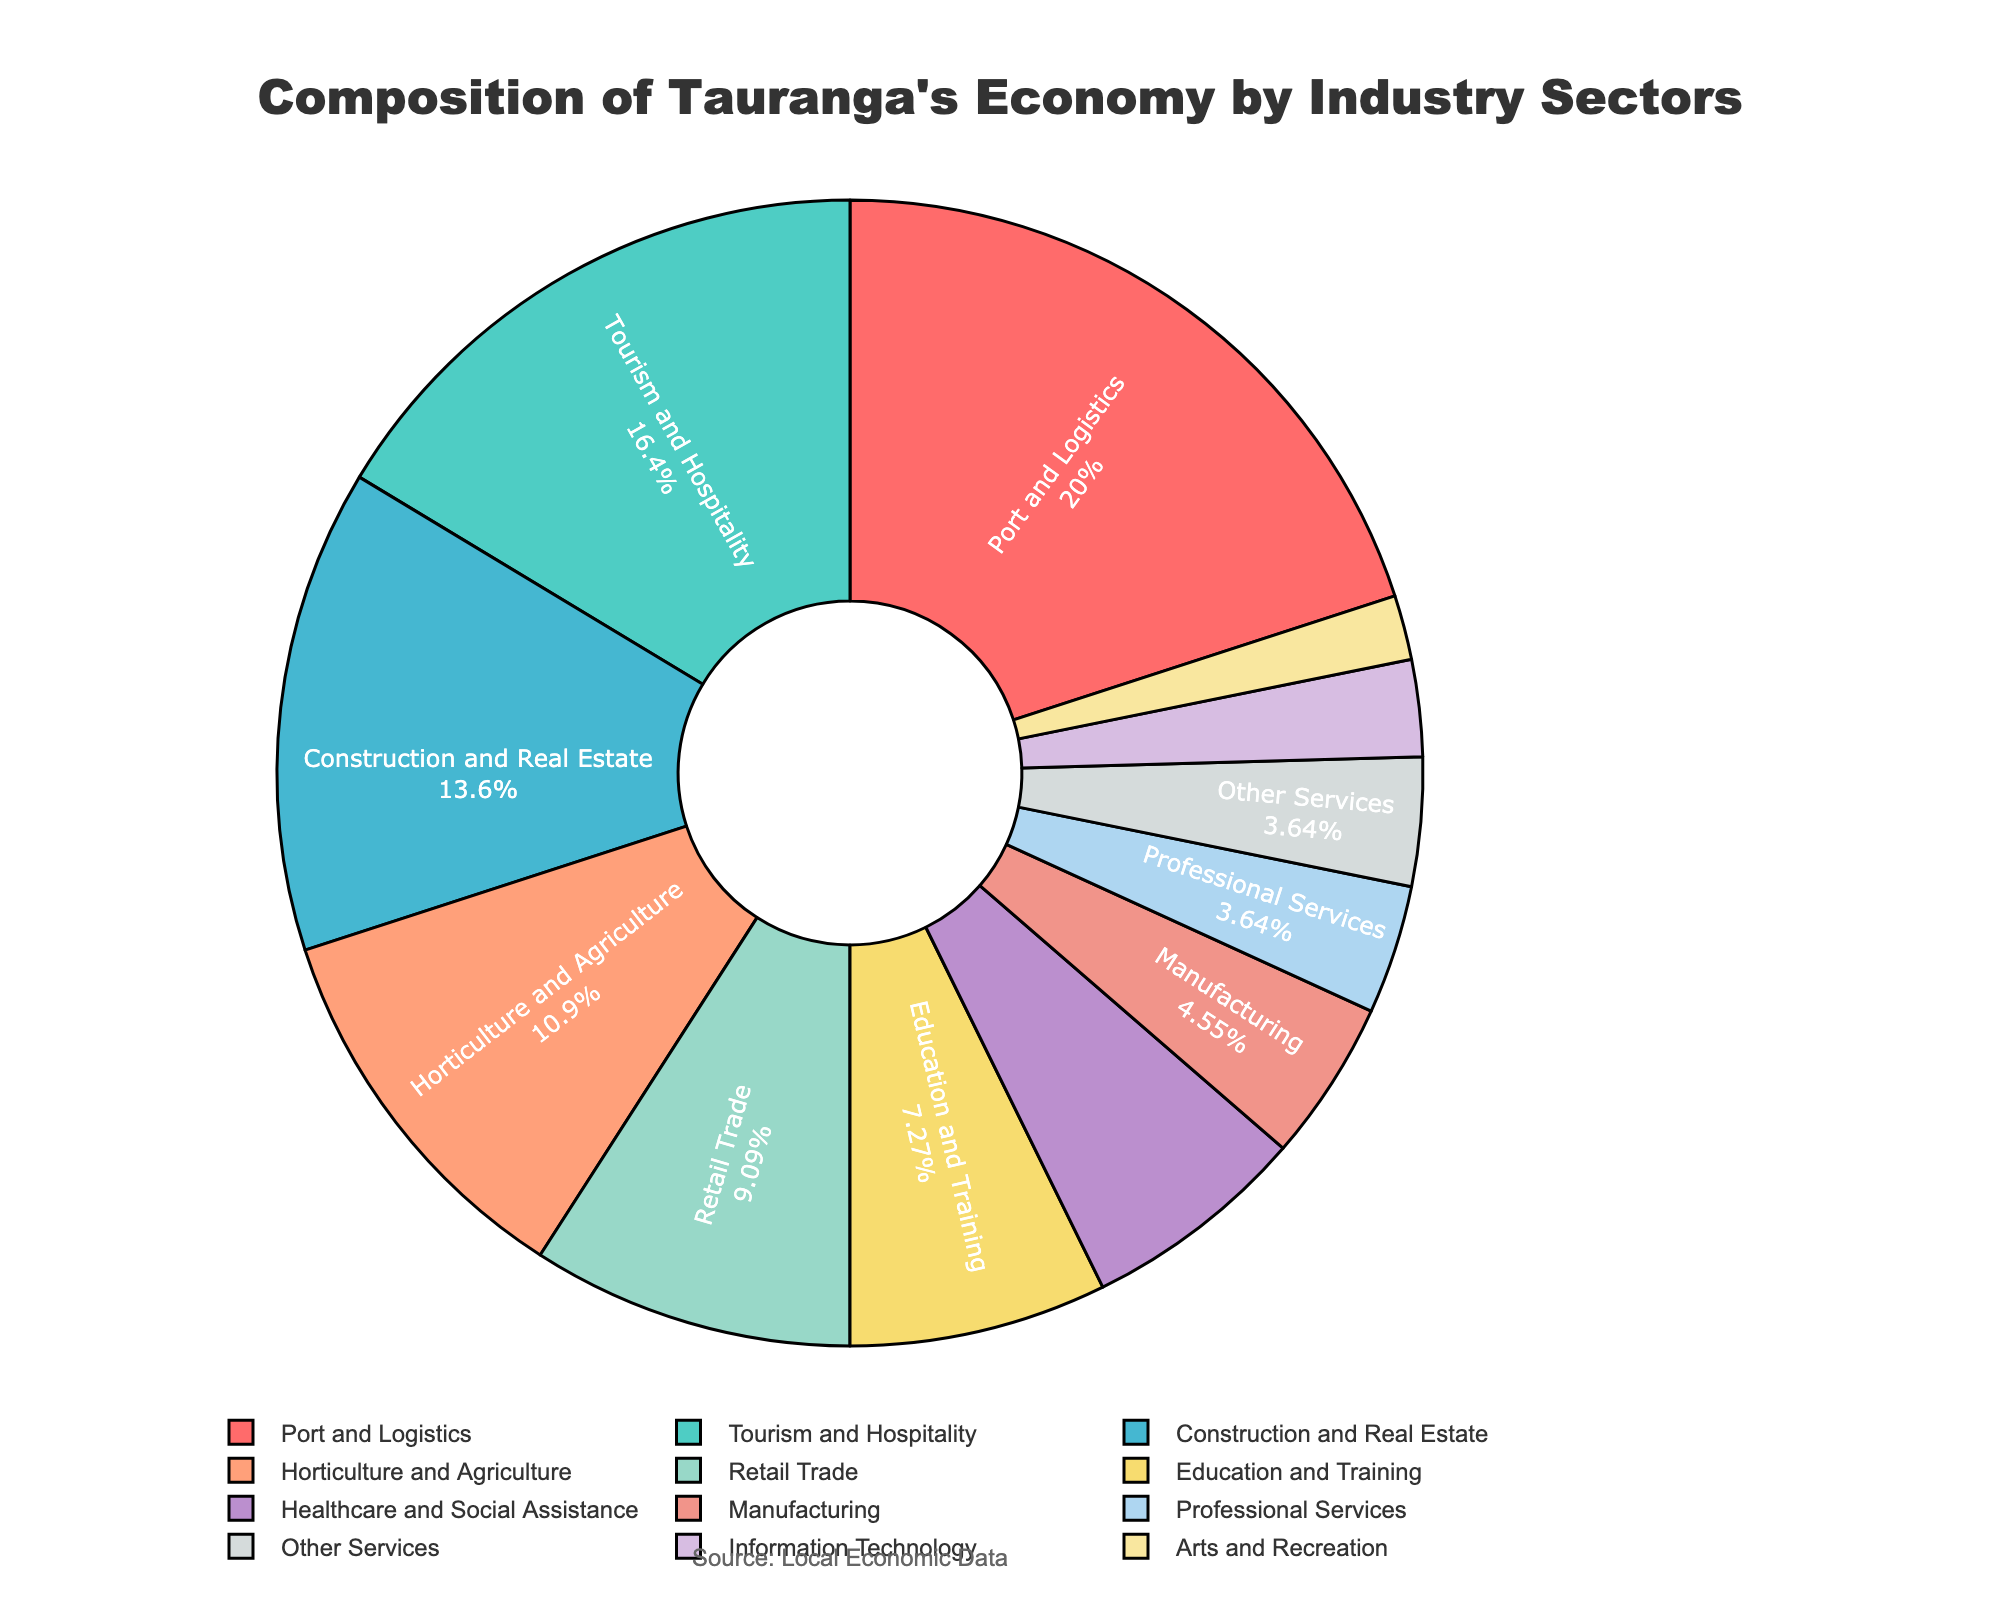Which industry sector is the largest contributor to Tauranga's economy? By examining the pie chart, the sector that occupies the largest segment is the one with the highest percentage. In this case, it's the Port and Logistics sector which is marked at 22%.
Answer: Port and Logistics What is the combined percentage of Tourism and Hospitality, and Horticulture and Agriculture? Add the percentages of the Tourism and Hospitality sector (18%) and the Horticulture and Agriculture sector (12%). The combined percentage is 18% + 12% = 30%.
Answer: 30% How does the contribution of Construction and Real Estate compare to Retail Trade? The pie chart shows Construction and Real Estate at 15% while Retail Trade is at 10%. Comparing these, Construction and Real Estate contributes 5% more than Retail Trade.
Answer: 5% more Which sector contributes the least to Tauranga's economy? By spotting the smallest segment in the pie chart, we identify the Arts and Recreation sector which is represented with 2%.
Answer: Arts and Recreation What is the total percentage contribution of Professional Services, Information Technology, and Arts and Recreation combined? Sum the percentages of Professional Services (4%), Information Technology (3%), and Arts and Recreation (2%). The total is 4% + 3% + 2% = 9%.
Answer: 9% Is the combined contribution of Healthcare and Social Assistance and Manufacturing greater or less than that of Construction and Real Estate? The combined contribution of Healthcare and Social Assistance (7%) and Manufacturing (5%) is 7% + 5% = 12%. This is less than the 15% contribution from Construction and Real Estate.
Answer: Less Identify the sector with the fourth highest contribution and state its percentage. Starting from the highest contributor, the fourth sector in the ranking is Horticulture and Agriculture with a percentage of 12%.
Answer: Horticulture and Agriculture, 12% What percentage of the economy is made up of sectors contributing 5% or less each? Add the percentages of Manufacturing (5%), Professional Services (4%), Information Technology (3%), Arts and Recreation (2%), and Other Services (4%). The total is 5% + 4% + 3% + 2% + 4% = 18%.
Answer: 18% 